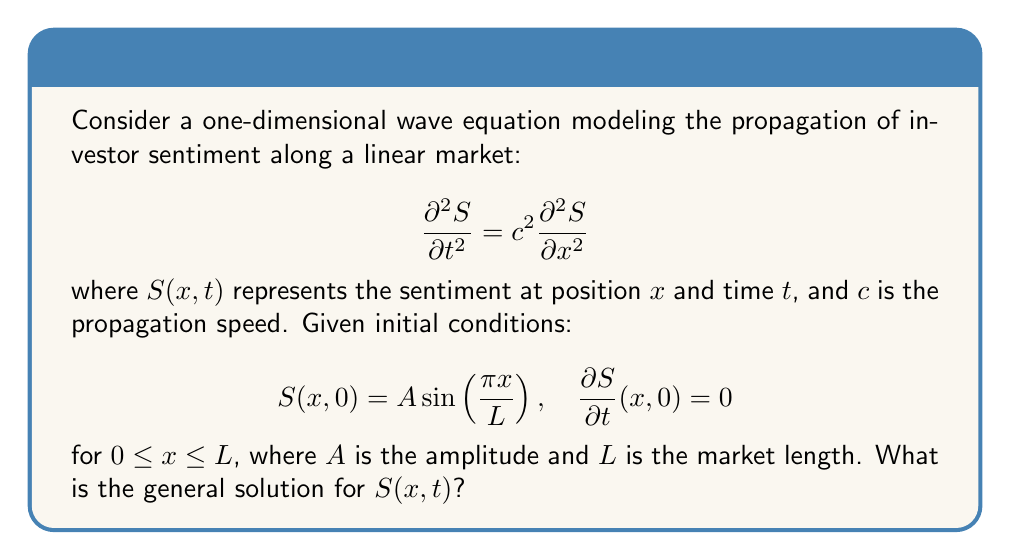Solve this math problem. To solve this wave equation with the given initial conditions, we'll follow these steps:

1) The general solution for a one-dimensional wave equation is of the form:

   $$S(x,t) = X(x)T(t)$$

2) Substituting this into the wave equation:

   $$X(x)T''(t) = c^2X''(x)T(t)$$

3) Separating variables:

   $$\frac{T''(t)}{c^2T(t)} = \frac{X''(x)}{X(x)} = -k^2$$

   where $k$ is a constant.

4) This leads to two separate equations:

   $$T''(t) + c^2k^2T(t) = 0$$
   $$X''(x) + k^2X(x) = 0$$

5) The general solutions for these are:

   $$T(t) = a \cos(ckt) + b \sin(ckt)$$
   $$X(x) = A \sin(kx) + B \cos(kx)$$

6) From the initial condition $S(x,0) = A \sin(\frac{\pi x}{L})$, we can deduce:

   $$k = \frac{\pi}{L}, \quad B = 0$$

7) The general solution becomes:

   $$S(x,t) = (a \cos(\frac{c\pi t}{L}) + b \sin(\frac{c\pi t}{L})) A \sin(\frac{\pi x}{L})$$

8) Using the second initial condition $\frac{\partial S}{\partial t}(x,0) = 0$:

   $$\frac{\partial S}{\partial t}(x,0) = (\frac{-ac\pi}{L} \sin(0) + \frac{bc\pi}{L} \cos(0)) A \sin(\frac{\pi x}{L}) = 0$$

   This implies $b = 0$.

9) Finally, to satisfy $S(x,0) = A \sin(\frac{\pi x}{L})$, we must have $a = 1$.

Therefore, the general solution is:

$$S(x,t) = A \cos(\frac{c\pi t}{L}) \sin(\frac{\pi x}{L})$$
Answer: $S(x,t) = A \cos(\frac{c\pi t}{L}) \sin(\frac{\pi x}{L})$ 